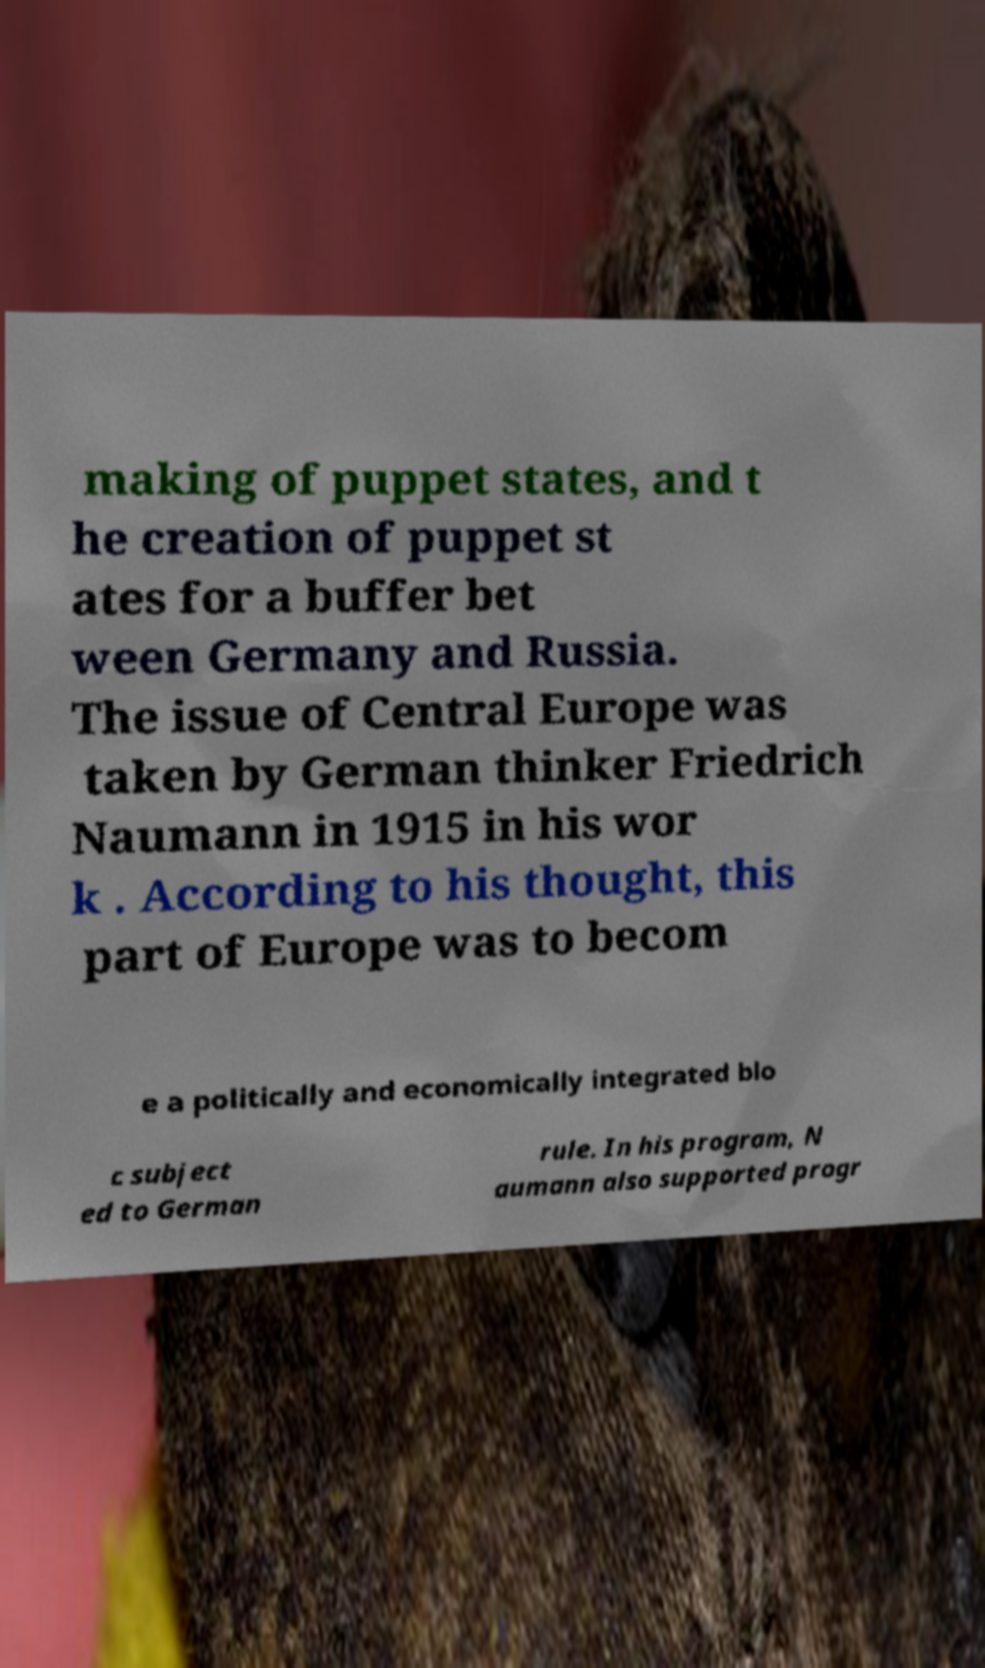Please identify and transcribe the text found in this image. making of puppet states, and t he creation of puppet st ates for a buffer bet ween Germany and Russia. The issue of Central Europe was taken by German thinker Friedrich Naumann in 1915 in his wor k . According to his thought, this part of Europe was to becom e a politically and economically integrated blo c subject ed to German rule. In his program, N aumann also supported progr 